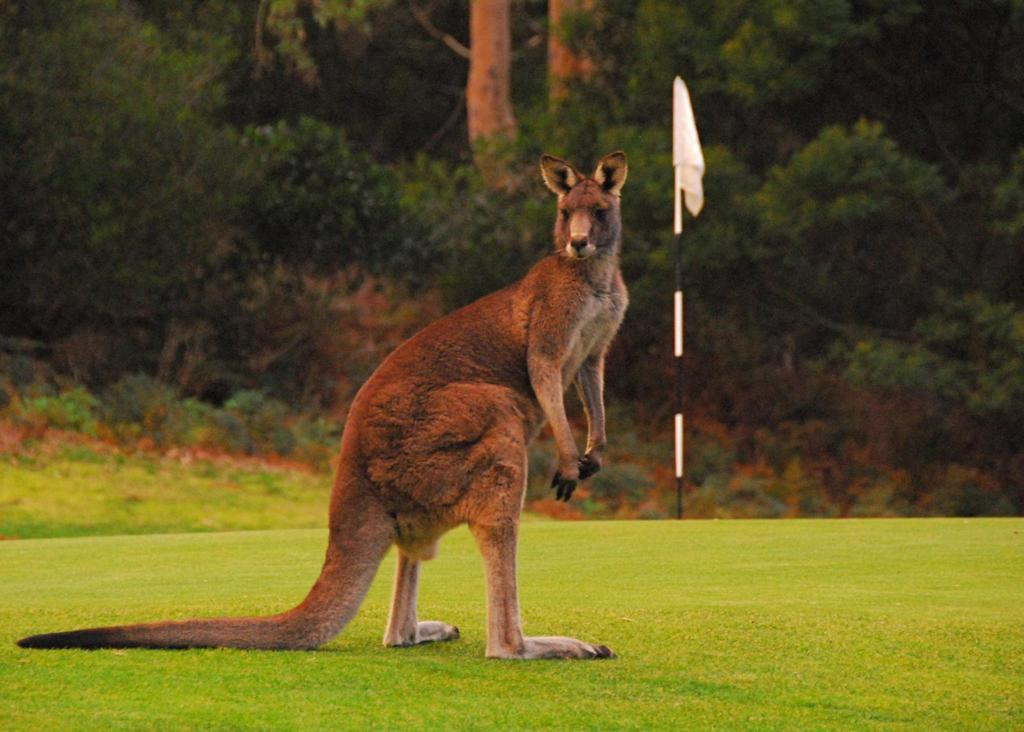What animal is the main subject of the picture? There is a kangaroo in the picture. What feature of the kangaroo is particularly noticeable? The kangaroo has a long tail. What type of terrain is visible in the picture? There is grass on the floor. What type of vegetation can be seen in the backdrop? There are plants and trees in the backdrop. What type of celery is the kangaroo eating in the picture? There is no celery present in the picture; the kangaroo is not eating anything. Can you tell me the name of the judge who is standing next to the kangaroo in the picture? There is no judge present in the picture; it only features a kangaroo. 